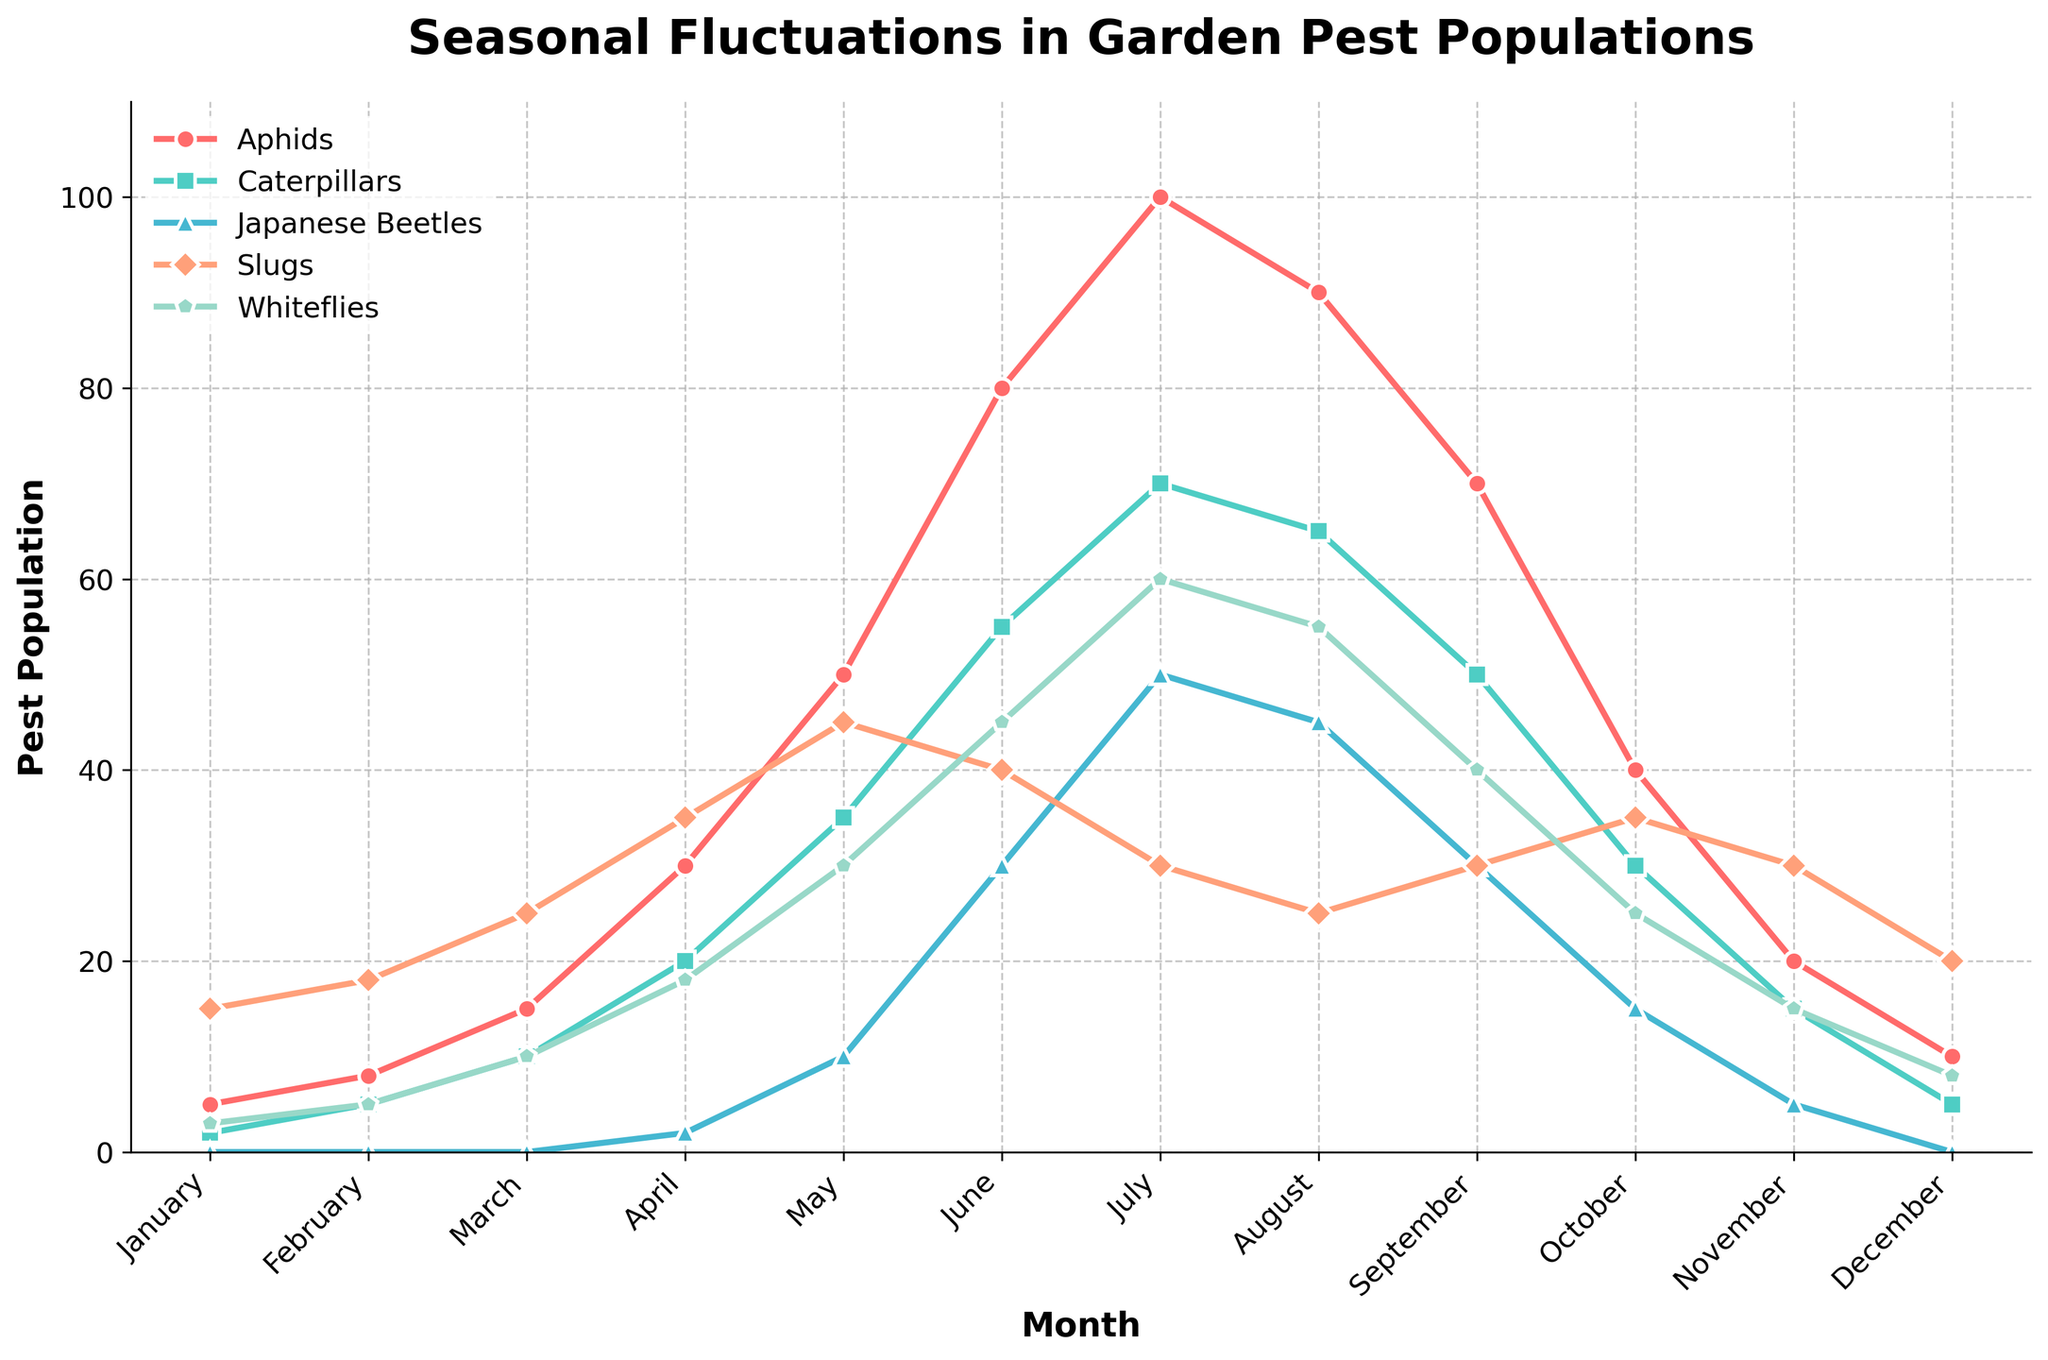What is the population of aphids in July? To find the population of aphids in July, locate the "Aphids" line on the graph at the point corresponding to July. The population at this point is 100.
Answer: 100 Which pest has the highest population in June? To determine the pest with the highest population in June, compare the data points for all pests in June. The pest with the highest population is Aphids with a population of 80.
Answer: Aphids In which month do slugs and caterpillars have the same population? To find the month where slugs and caterpillars have the same population, observe the lines for both over the months. The population of slugs and caterpillars is the same in November, which is 30.
Answer: November How does the population of whiteflies change from March to April? Check the whiteflies line on the graph from March to April. The population increases from 10 in March to 18 in April, an increase of 8.
Answer: Increase by 8 What is the average population of Japanese Beetles from May to July? Sum the populations of Japanese Beetles for May (10), June (30), and July (50). Then, divide by the number of months (3). The calculation is (10 + 30 + 50) / 3 = 30.
Answer: 30 Which month shows the highest fluctuation in population for any pest, and which pest is it? The month with the highest fluctuation in population is July. Aphids have a peak population of 100 in this month.
Answer: July, Aphids Compare the population of whiteflies and slugs in September. Which one is higher and by how much? In September, the population of whiteflies is 40, and slugs is 30. The difference is 40 - 30 = 10, so whiteflies are higher by 10.
Answer: Whiteflies by 10 Between January and June, what is the overall trend for the population of caterpillars? By observing the trend line for caterpillars from January (2) to June (55), we can see a steady increase in the population over these months.
Answer: Steady increase How much does the population of aphids decrease from July to December? The population of aphids decreases from 100 in July to 10 in December. The decrease equals 100 - 10 = 90.
Answer: Decrease by 90 In which month do all pests have their lowest combined population, and what is that combined population? Calculate the combined populations for each month and compare. The lowest combined population is in January: 5 (aphids) + 2 (caterpillars) + 0 (Japanese beetles) + 15 (slugs) + 3 (whiteflies) = 25.
Answer: January, 25 